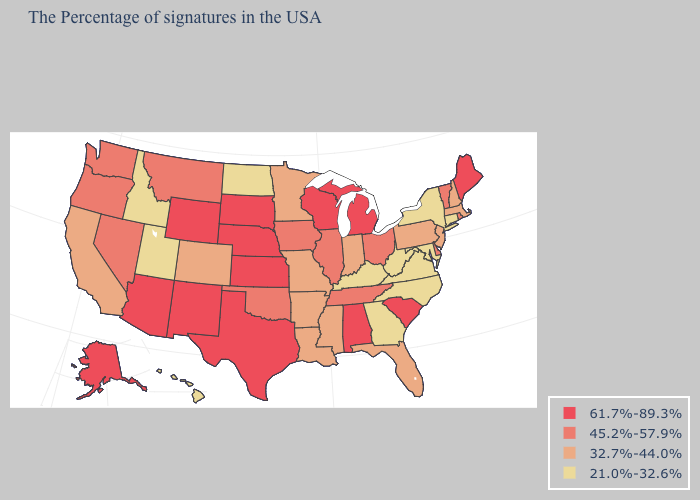Among the states that border Wisconsin , does Michigan have the highest value?
Answer briefly. Yes. Among the states that border Ohio , which have the highest value?
Quick response, please. Michigan. What is the value of Iowa?
Write a very short answer. 45.2%-57.9%. What is the value of Alaska?
Keep it brief. 61.7%-89.3%. What is the highest value in the USA?
Write a very short answer. 61.7%-89.3%. Name the states that have a value in the range 32.7%-44.0%?
Answer briefly. Massachusetts, New Hampshire, New Jersey, Pennsylvania, Florida, Indiana, Mississippi, Louisiana, Missouri, Arkansas, Minnesota, Colorado, California. What is the value of Missouri?
Give a very brief answer. 32.7%-44.0%. Does Montana have a higher value than Tennessee?
Concise answer only. No. How many symbols are there in the legend?
Keep it brief. 4. What is the value of Hawaii?
Write a very short answer. 21.0%-32.6%. Does the map have missing data?
Answer briefly. No. Is the legend a continuous bar?
Quick response, please. No. How many symbols are there in the legend?
Be succinct. 4. What is the lowest value in the South?
Short answer required. 21.0%-32.6%. Name the states that have a value in the range 21.0%-32.6%?
Give a very brief answer. Connecticut, New York, Maryland, Virginia, North Carolina, West Virginia, Georgia, Kentucky, North Dakota, Utah, Idaho, Hawaii. 